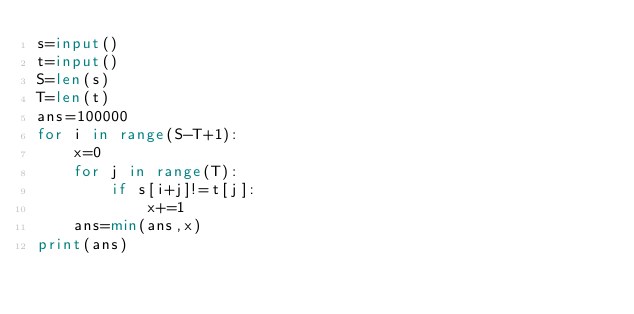<code> <loc_0><loc_0><loc_500><loc_500><_Python_>s=input()
t=input()
S=len(s)
T=len(t)
ans=100000
for i in range(S-T+1):
    x=0
    for j in range(T):
        if s[i+j]!=t[j]:
            x+=1
    ans=min(ans,x)
print(ans)</code> 